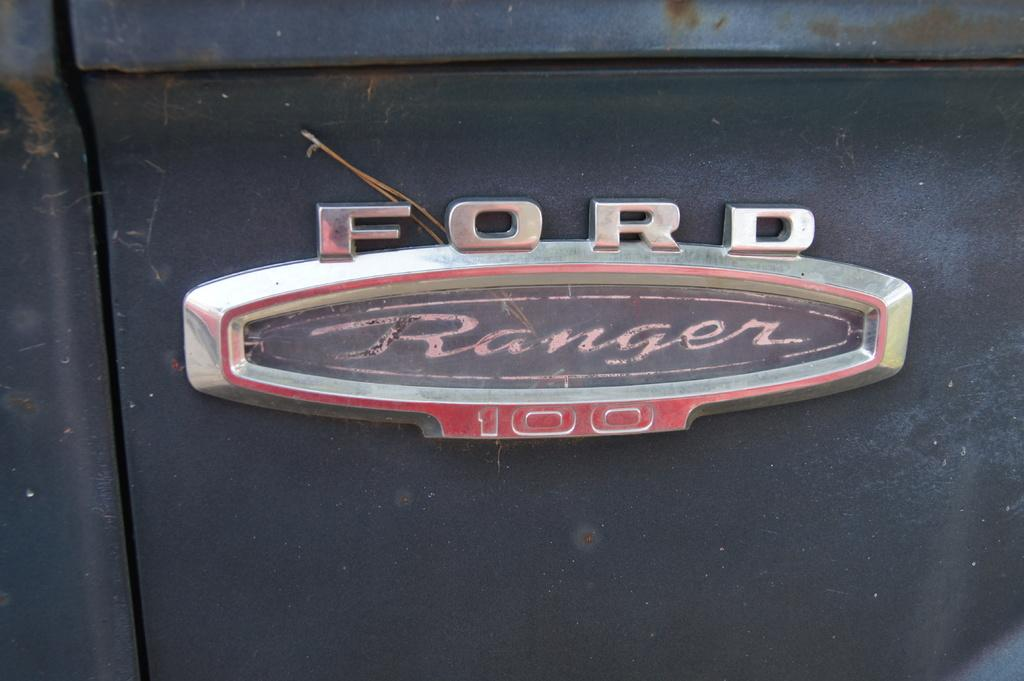What is the main subject of the image? The main subject of the image is a logo made of metal. What is written or depicted on the logo? The logo has text on it. Is the logo connected to any other objects in the image? Yes, the logo is attached to another metal object. How many fish are swimming around the metal logo in the image? There are no fish present in the image. 